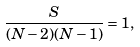Convert formula to latex. <formula><loc_0><loc_0><loc_500><loc_500>\frac { S } { ( N - 2 ) ( N - 1 ) } = 1 ,</formula> 